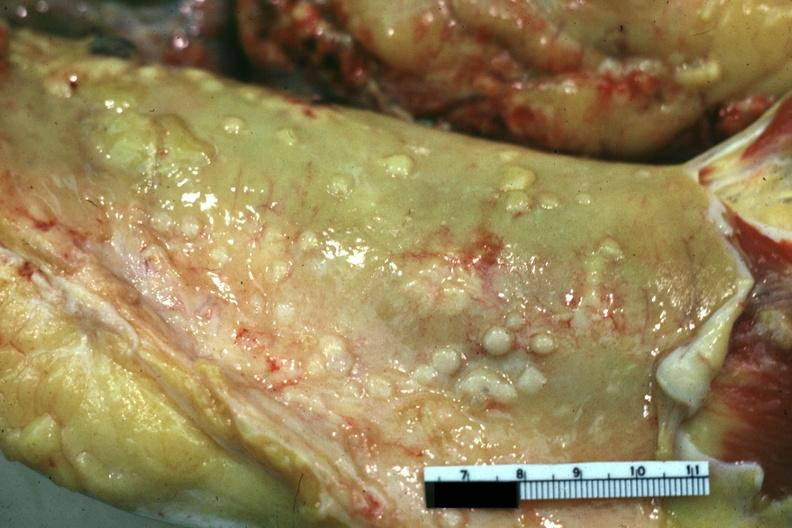what does this image show?
Answer the question using a single word or phrase. Close-up view of metastatic lesions color not the best papillary serous adenocarcinoma of ovary 